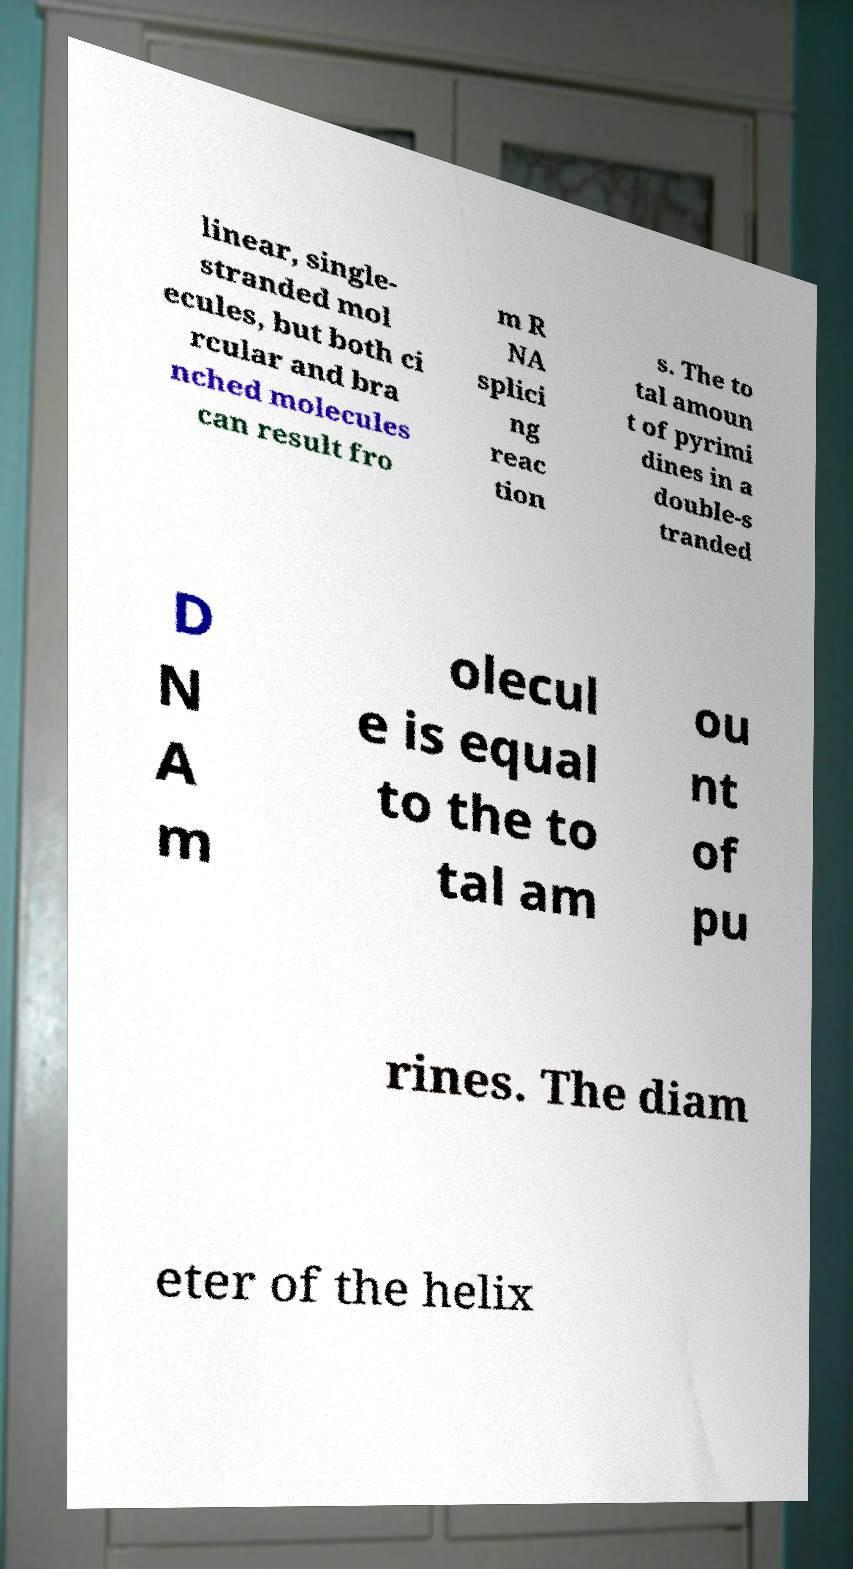Can you accurately transcribe the text from the provided image for me? linear, single- stranded mol ecules, but both ci rcular and bra nched molecules can result fro m R NA splici ng reac tion s. The to tal amoun t of pyrimi dines in a double-s tranded D N A m olecul e is equal to the to tal am ou nt of pu rines. The diam eter of the helix 